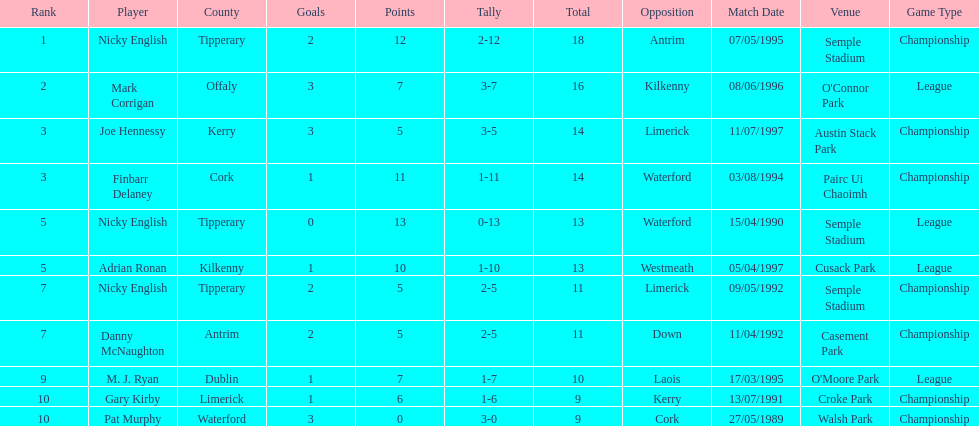What player got 10 total points in their game? M. J. Ryan. 